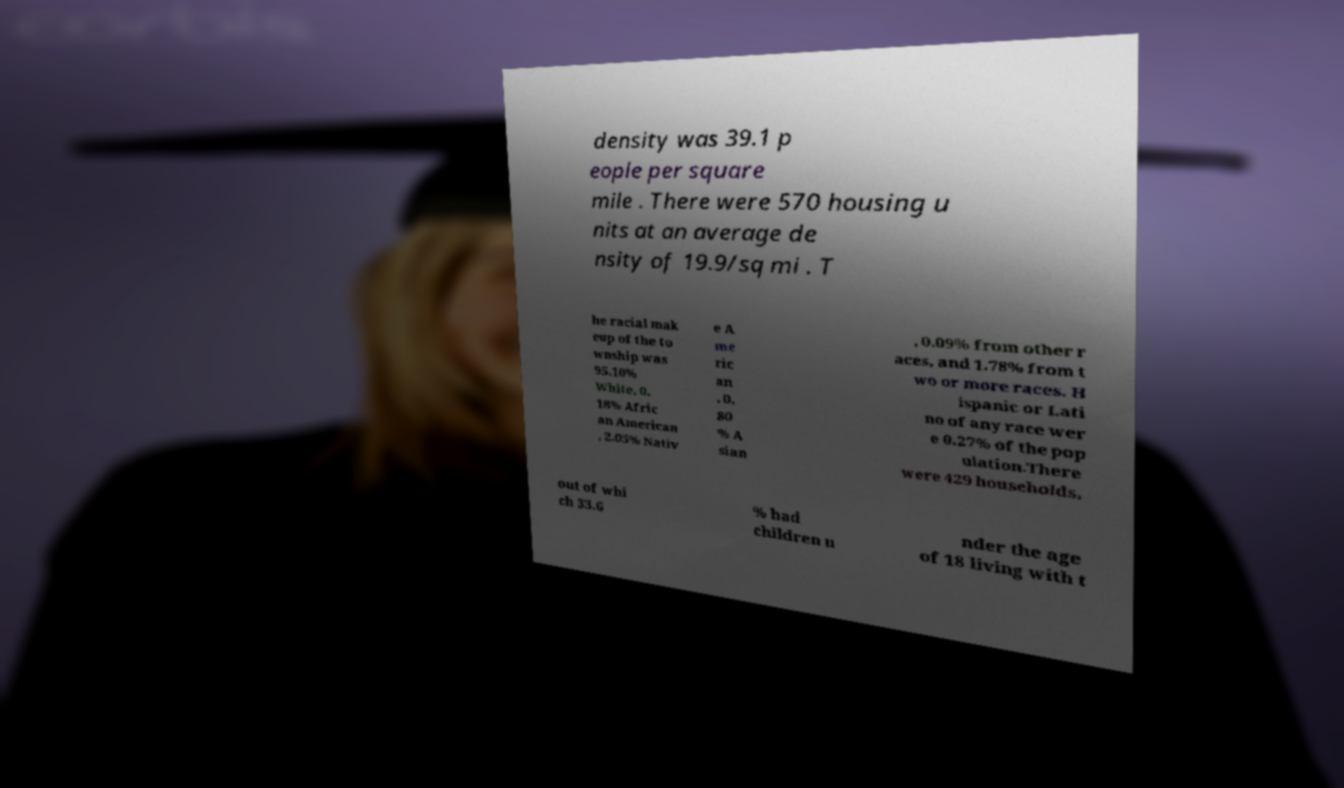Could you extract and type out the text from this image? density was 39.1 p eople per square mile . There were 570 housing u nits at an average de nsity of 19.9/sq mi . T he racial mak eup of the to wnship was 95.10% White, 0. 18% Afric an American , 2.05% Nativ e A me ric an , 0. 80 % A sian , 0.09% from other r aces, and 1.78% from t wo or more races. H ispanic or Lati no of any race wer e 0.27% of the pop ulation.There were 429 households, out of whi ch 33.6 % had children u nder the age of 18 living with t 